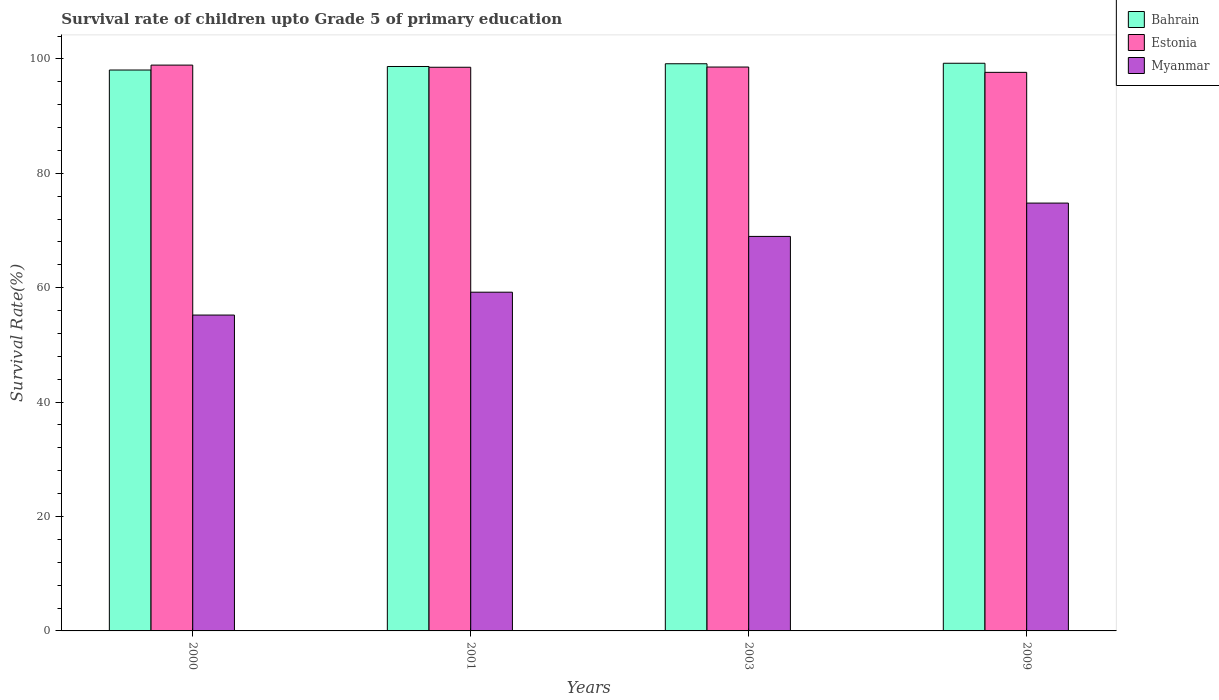How many different coloured bars are there?
Keep it short and to the point. 3. How many groups of bars are there?
Keep it short and to the point. 4. Are the number of bars per tick equal to the number of legend labels?
Your answer should be very brief. Yes. Are the number of bars on each tick of the X-axis equal?
Make the answer very short. Yes. How many bars are there on the 1st tick from the left?
Ensure brevity in your answer.  3. How many bars are there on the 2nd tick from the right?
Your response must be concise. 3. In how many cases, is the number of bars for a given year not equal to the number of legend labels?
Offer a very short reply. 0. What is the survival rate of children in Estonia in 2003?
Give a very brief answer. 98.57. Across all years, what is the maximum survival rate of children in Estonia?
Offer a terse response. 98.91. Across all years, what is the minimum survival rate of children in Myanmar?
Offer a terse response. 55.22. In which year was the survival rate of children in Estonia maximum?
Provide a short and direct response. 2000. What is the total survival rate of children in Bahrain in the graph?
Offer a very short reply. 395.11. What is the difference between the survival rate of children in Myanmar in 2000 and that in 2009?
Offer a very short reply. -19.58. What is the difference between the survival rate of children in Bahrain in 2000 and the survival rate of children in Myanmar in 2009?
Offer a very short reply. 23.26. What is the average survival rate of children in Myanmar per year?
Make the answer very short. 64.55. In the year 2000, what is the difference between the survival rate of children in Myanmar and survival rate of children in Estonia?
Provide a succinct answer. -43.7. What is the ratio of the survival rate of children in Myanmar in 2000 to that in 2001?
Offer a very short reply. 0.93. Is the survival rate of children in Bahrain in 2000 less than that in 2009?
Provide a short and direct response. Yes. What is the difference between the highest and the second highest survival rate of children in Bahrain?
Offer a very short reply. 0.09. What is the difference between the highest and the lowest survival rate of children in Bahrain?
Offer a very short reply. 1.18. In how many years, is the survival rate of children in Estonia greater than the average survival rate of children in Estonia taken over all years?
Provide a succinct answer. 3. What does the 3rd bar from the left in 2000 represents?
Offer a very short reply. Myanmar. What does the 1st bar from the right in 2000 represents?
Keep it short and to the point. Myanmar. How many bars are there?
Make the answer very short. 12. How many years are there in the graph?
Keep it short and to the point. 4. Where does the legend appear in the graph?
Give a very brief answer. Top right. What is the title of the graph?
Make the answer very short. Survival rate of children upto Grade 5 of primary education. What is the label or title of the X-axis?
Make the answer very short. Years. What is the label or title of the Y-axis?
Provide a succinct answer. Survival Rate(%). What is the Survival Rate(%) in Bahrain in 2000?
Make the answer very short. 98.05. What is the Survival Rate(%) of Estonia in 2000?
Provide a short and direct response. 98.91. What is the Survival Rate(%) in Myanmar in 2000?
Give a very brief answer. 55.22. What is the Survival Rate(%) in Bahrain in 2001?
Your response must be concise. 98.67. What is the Survival Rate(%) of Estonia in 2001?
Your answer should be compact. 98.54. What is the Survival Rate(%) in Myanmar in 2001?
Provide a succinct answer. 59.21. What is the Survival Rate(%) in Bahrain in 2003?
Give a very brief answer. 99.15. What is the Survival Rate(%) in Estonia in 2003?
Ensure brevity in your answer.  98.57. What is the Survival Rate(%) in Myanmar in 2003?
Give a very brief answer. 68.96. What is the Survival Rate(%) of Bahrain in 2009?
Give a very brief answer. 99.24. What is the Survival Rate(%) in Estonia in 2009?
Your answer should be compact. 97.65. What is the Survival Rate(%) in Myanmar in 2009?
Your answer should be compact. 74.79. Across all years, what is the maximum Survival Rate(%) of Bahrain?
Provide a succinct answer. 99.24. Across all years, what is the maximum Survival Rate(%) of Estonia?
Your response must be concise. 98.91. Across all years, what is the maximum Survival Rate(%) of Myanmar?
Keep it short and to the point. 74.79. Across all years, what is the minimum Survival Rate(%) in Bahrain?
Make the answer very short. 98.05. Across all years, what is the minimum Survival Rate(%) of Estonia?
Provide a succinct answer. 97.65. Across all years, what is the minimum Survival Rate(%) of Myanmar?
Provide a short and direct response. 55.22. What is the total Survival Rate(%) in Bahrain in the graph?
Give a very brief answer. 395.11. What is the total Survival Rate(%) of Estonia in the graph?
Make the answer very short. 393.67. What is the total Survival Rate(%) in Myanmar in the graph?
Your answer should be compact. 258.19. What is the difference between the Survival Rate(%) in Bahrain in 2000 and that in 2001?
Provide a short and direct response. -0.62. What is the difference between the Survival Rate(%) of Estonia in 2000 and that in 2001?
Make the answer very short. 0.38. What is the difference between the Survival Rate(%) in Myanmar in 2000 and that in 2001?
Provide a succinct answer. -4. What is the difference between the Survival Rate(%) in Bahrain in 2000 and that in 2003?
Provide a short and direct response. -1.1. What is the difference between the Survival Rate(%) in Estonia in 2000 and that in 2003?
Ensure brevity in your answer.  0.34. What is the difference between the Survival Rate(%) of Myanmar in 2000 and that in 2003?
Your answer should be compact. -13.75. What is the difference between the Survival Rate(%) in Bahrain in 2000 and that in 2009?
Make the answer very short. -1.18. What is the difference between the Survival Rate(%) of Estonia in 2000 and that in 2009?
Give a very brief answer. 1.27. What is the difference between the Survival Rate(%) in Myanmar in 2000 and that in 2009?
Your response must be concise. -19.58. What is the difference between the Survival Rate(%) in Bahrain in 2001 and that in 2003?
Your answer should be very brief. -0.48. What is the difference between the Survival Rate(%) of Estonia in 2001 and that in 2003?
Ensure brevity in your answer.  -0.04. What is the difference between the Survival Rate(%) of Myanmar in 2001 and that in 2003?
Your answer should be very brief. -9.75. What is the difference between the Survival Rate(%) of Bahrain in 2001 and that in 2009?
Your answer should be very brief. -0.57. What is the difference between the Survival Rate(%) of Estonia in 2001 and that in 2009?
Provide a short and direct response. 0.89. What is the difference between the Survival Rate(%) in Myanmar in 2001 and that in 2009?
Make the answer very short. -15.58. What is the difference between the Survival Rate(%) of Bahrain in 2003 and that in 2009?
Make the answer very short. -0.09. What is the difference between the Survival Rate(%) in Estonia in 2003 and that in 2009?
Your answer should be very brief. 0.93. What is the difference between the Survival Rate(%) of Myanmar in 2003 and that in 2009?
Your response must be concise. -5.83. What is the difference between the Survival Rate(%) of Bahrain in 2000 and the Survival Rate(%) of Estonia in 2001?
Your response must be concise. -0.48. What is the difference between the Survival Rate(%) of Bahrain in 2000 and the Survival Rate(%) of Myanmar in 2001?
Provide a short and direct response. 38.84. What is the difference between the Survival Rate(%) of Estonia in 2000 and the Survival Rate(%) of Myanmar in 2001?
Your answer should be very brief. 39.7. What is the difference between the Survival Rate(%) of Bahrain in 2000 and the Survival Rate(%) of Estonia in 2003?
Offer a very short reply. -0.52. What is the difference between the Survival Rate(%) in Bahrain in 2000 and the Survival Rate(%) in Myanmar in 2003?
Make the answer very short. 29.09. What is the difference between the Survival Rate(%) in Estonia in 2000 and the Survival Rate(%) in Myanmar in 2003?
Offer a very short reply. 29.95. What is the difference between the Survival Rate(%) of Bahrain in 2000 and the Survival Rate(%) of Estonia in 2009?
Your response must be concise. 0.4. What is the difference between the Survival Rate(%) in Bahrain in 2000 and the Survival Rate(%) in Myanmar in 2009?
Provide a succinct answer. 23.26. What is the difference between the Survival Rate(%) in Estonia in 2000 and the Survival Rate(%) in Myanmar in 2009?
Provide a succinct answer. 24.12. What is the difference between the Survival Rate(%) of Bahrain in 2001 and the Survival Rate(%) of Estonia in 2003?
Your answer should be compact. 0.1. What is the difference between the Survival Rate(%) of Bahrain in 2001 and the Survival Rate(%) of Myanmar in 2003?
Make the answer very short. 29.71. What is the difference between the Survival Rate(%) of Estonia in 2001 and the Survival Rate(%) of Myanmar in 2003?
Make the answer very short. 29.57. What is the difference between the Survival Rate(%) of Bahrain in 2001 and the Survival Rate(%) of Estonia in 2009?
Provide a succinct answer. 1.02. What is the difference between the Survival Rate(%) in Bahrain in 2001 and the Survival Rate(%) in Myanmar in 2009?
Offer a terse response. 23.88. What is the difference between the Survival Rate(%) in Estonia in 2001 and the Survival Rate(%) in Myanmar in 2009?
Give a very brief answer. 23.74. What is the difference between the Survival Rate(%) of Bahrain in 2003 and the Survival Rate(%) of Estonia in 2009?
Your response must be concise. 1.5. What is the difference between the Survival Rate(%) of Bahrain in 2003 and the Survival Rate(%) of Myanmar in 2009?
Give a very brief answer. 24.36. What is the difference between the Survival Rate(%) in Estonia in 2003 and the Survival Rate(%) in Myanmar in 2009?
Your answer should be very brief. 23.78. What is the average Survival Rate(%) of Bahrain per year?
Make the answer very short. 98.78. What is the average Survival Rate(%) of Estonia per year?
Give a very brief answer. 98.42. What is the average Survival Rate(%) of Myanmar per year?
Your response must be concise. 64.55. In the year 2000, what is the difference between the Survival Rate(%) of Bahrain and Survival Rate(%) of Estonia?
Ensure brevity in your answer.  -0.86. In the year 2000, what is the difference between the Survival Rate(%) in Bahrain and Survival Rate(%) in Myanmar?
Give a very brief answer. 42.83. In the year 2000, what is the difference between the Survival Rate(%) in Estonia and Survival Rate(%) in Myanmar?
Make the answer very short. 43.7. In the year 2001, what is the difference between the Survival Rate(%) in Bahrain and Survival Rate(%) in Estonia?
Ensure brevity in your answer.  0.13. In the year 2001, what is the difference between the Survival Rate(%) in Bahrain and Survival Rate(%) in Myanmar?
Provide a succinct answer. 39.46. In the year 2001, what is the difference between the Survival Rate(%) in Estonia and Survival Rate(%) in Myanmar?
Ensure brevity in your answer.  39.32. In the year 2003, what is the difference between the Survival Rate(%) of Bahrain and Survival Rate(%) of Estonia?
Offer a very short reply. 0.57. In the year 2003, what is the difference between the Survival Rate(%) in Bahrain and Survival Rate(%) in Myanmar?
Offer a very short reply. 30.18. In the year 2003, what is the difference between the Survival Rate(%) in Estonia and Survival Rate(%) in Myanmar?
Offer a very short reply. 29.61. In the year 2009, what is the difference between the Survival Rate(%) in Bahrain and Survival Rate(%) in Estonia?
Provide a succinct answer. 1.59. In the year 2009, what is the difference between the Survival Rate(%) of Bahrain and Survival Rate(%) of Myanmar?
Ensure brevity in your answer.  24.44. In the year 2009, what is the difference between the Survival Rate(%) in Estonia and Survival Rate(%) in Myanmar?
Offer a very short reply. 22.85. What is the ratio of the Survival Rate(%) of Myanmar in 2000 to that in 2001?
Make the answer very short. 0.93. What is the ratio of the Survival Rate(%) of Bahrain in 2000 to that in 2003?
Provide a succinct answer. 0.99. What is the ratio of the Survival Rate(%) of Myanmar in 2000 to that in 2003?
Provide a short and direct response. 0.8. What is the ratio of the Survival Rate(%) of Myanmar in 2000 to that in 2009?
Offer a terse response. 0.74. What is the ratio of the Survival Rate(%) in Myanmar in 2001 to that in 2003?
Offer a terse response. 0.86. What is the ratio of the Survival Rate(%) in Estonia in 2001 to that in 2009?
Offer a very short reply. 1.01. What is the ratio of the Survival Rate(%) of Myanmar in 2001 to that in 2009?
Make the answer very short. 0.79. What is the ratio of the Survival Rate(%) of Estonia in 2003 to that in 2009?
Your response must be concise. 1.01. What is the ratio of the Survival Rate(%) in Myanmar in 2003 to that in 2009?
Your answer should be very brief. 0.92. What is the difference between the highest and the second highest Survival Rate(%) of Bahrain?
Provide a short and direct response. 0.09. What is the difference between the highest and the second highest Survival Rate(%) of Estonia?
Offer a very short reply. 0.34. What is the difference between the highest and the second highest Survival Rate(%) in Myanmar?
Give a very brief answer. 5.83. What is the difference between the highest and the lowest Survival Rate(%) in Bahrain?
Make the answer very short. 1.18. What is the difference between the highest and the lowest Survival Rate(%) of Estonia?
Keep it short and to the point. 1.27. What is the difference between the highest and the lowest Survival Rate(%) in Myanmar?
Give a very brief answer. 19.58. 